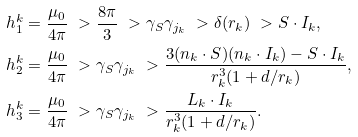<formula> <loc_0><loc_0><loc_500><loc_500>h _ { 1 } ^ { k } & = \frac { \mu _ { 0 } } { 4 \pi } \ > \frac { 8 \pi } { 3 } \ > \gamma _ { S } \gamma _ { j _ { k } } \ > \delta ( r _ { k } ) \ > S \cdot I _ { k } , \\ h _ { 2 } ^ { k } & = \frac { \mu _ { 0 } } { 4 \pi } \ > \gamma _ { S } \gamma _ { j _ { k } } \ > \frac { 3 ( n _ { k } \cdot S ) ( n _ { k } \cdot I _ { k } ) - S \cdot I _ { k } } { r _ { k } ^ { 3 } ( 1 + d / r _ { k } ) } , \\ h _ { 3 } ^ { k } & = \frac { \mu _ { 0 } } { 4 \pi } \ > \gamma _ { S } \gamma _ { j _ { k } } \ > \frac { L _ { k } \cdot I _ { k } } { r _ { k } ^ { 3 } ( 1 + d / r _ { k } ) } .</formula> 